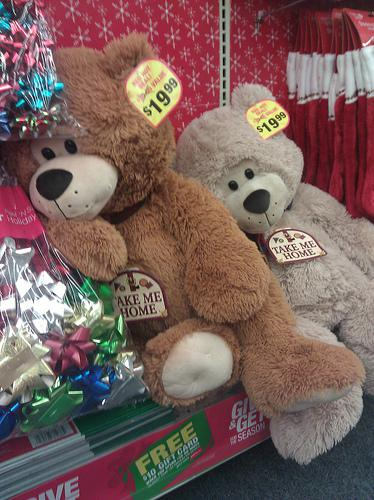Question: what time of year does it appear to be?
Choices:
A. Summer.
B. Spring.
C. Christmas Time.
D. Winter.
Answer with the letter. Answer: C Question: what color is the bear on the left?
Choices:
A. White.
B. Black.
C. Gray.
D. Brown.
Answer with the letter. Answer: D Question: how many bears are in this picture?
Choices:
A. Four.
B. Three.
C. Two.
D. One.
Answer with the letter. Answer: C Question: what does the tag on the bears chest say?
Choices:
A. Hug me.
B. Love me.
C. Take me home.
D. Buy me.
Answer with the letter. Answer: C 